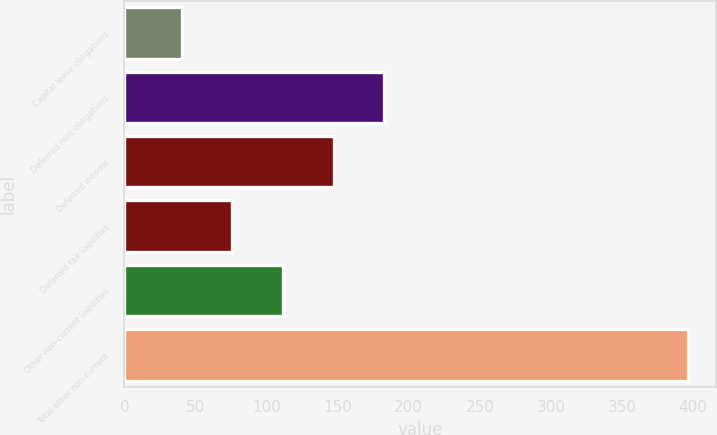Convert chart. <chart><loc_0><loc_0><loc_500><loc_500><bar_chart><fcel>Capital lease obligations<fcel>Deferred rent obligations<fcel>Deferred income<fcel>Deferred tax liabilities<fcel>Other non-current liabilities<fcel>Total other non-current<nl><fcel>40.4<fcel>182.68<fcel>147.11<fcel>75.97<fcel>111.54<fcel>396.1<nl></chart> 